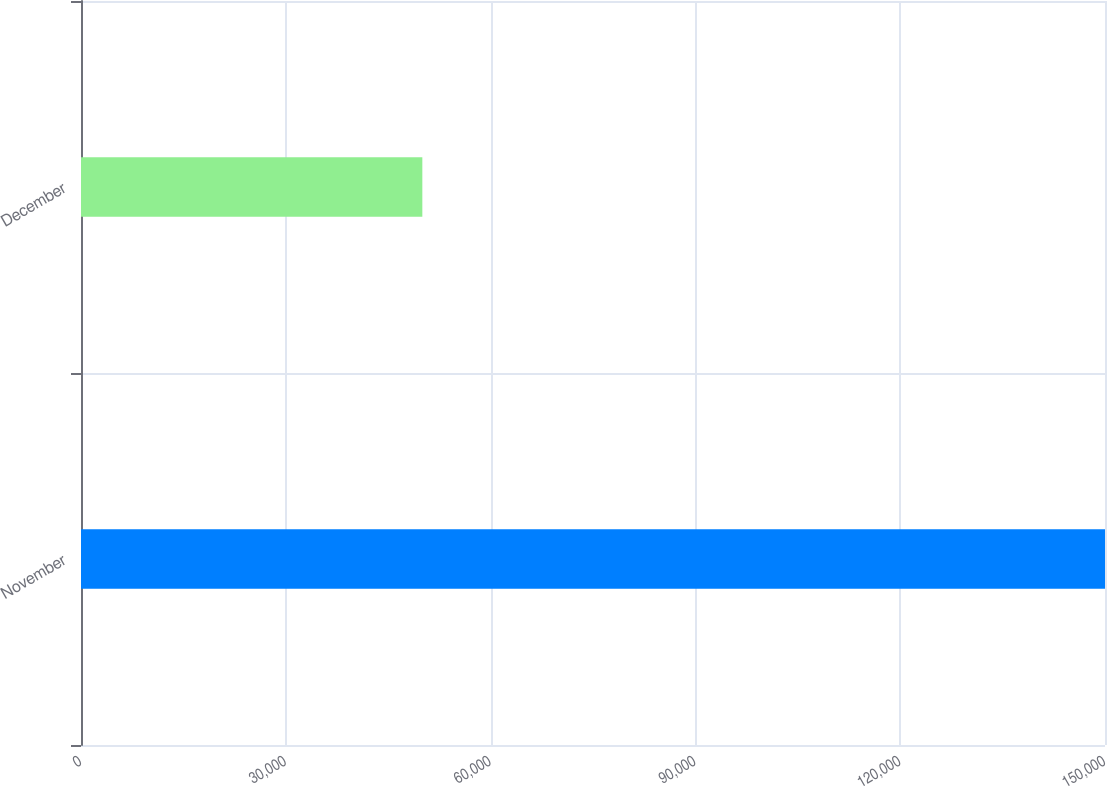<chart> <loc_0><loc_0><loc_500><loc_500><bar_chart><fcel>November<fcel>December<nl><fcel>150000<fcel>50000<nl></chart> 